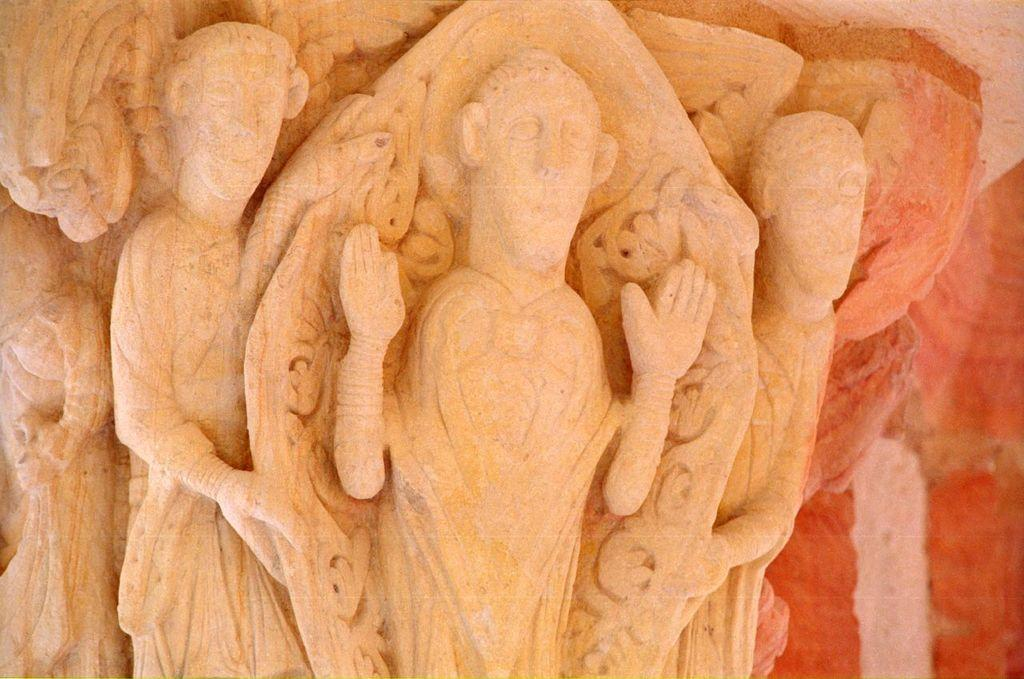What can be seen on the left side of the image? There are sculptures on a pillar on the left side of the image. Can you describe the background of the image? The background of the image is blurred. What type of feeling does the channel in the image evoke? There is no channel present in the image, so it cannot evoke any feelings. 